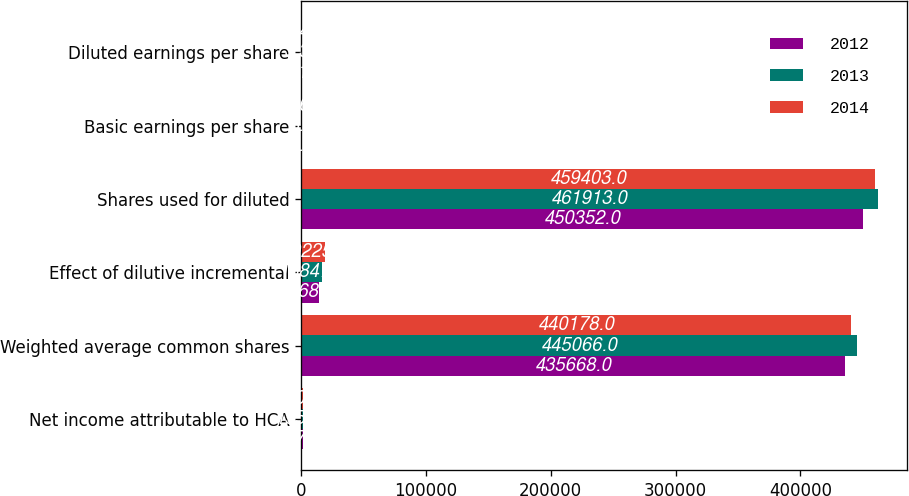Convert chart to OTSL. <chart><loc_0><loc_0><loc_500><loc_500><stacked_bar_chart><ecel><fcel>Net income attributable to HCA<fcel>Weighted average common shares<fcel>Effect of dilutive incremental<fcel>Shares used for diluted<fcel>Basic earnings per share<fcel>Diluted earnings per share<nl><fcel>2012<fcel>1875<fcel>435668<fcel>14684<fcel>450352<fcel>4.3<fcel>4.16<nl><fcel>2013<fcel>1556<fcel>445066<fcel>16847<fcel>461913<fcel>3.5<fcel>3.37<nl><fcel>2014<fcel>1605<fcel>440178<fcel>19225<fcel>459403<fcel>3.65<fcel>3.49<nl></chart> 